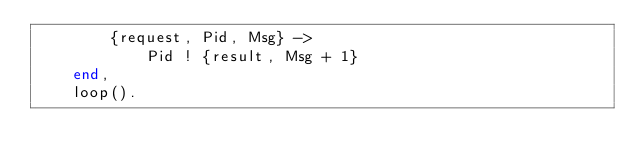Convert code to text. <code><loc_0><loc_0><loc_500><loc_500><_Erlang_>        {request, Pid, Msg} ->
            Pid ! {result, Msg + 1}
    end,
    loop().</code> 